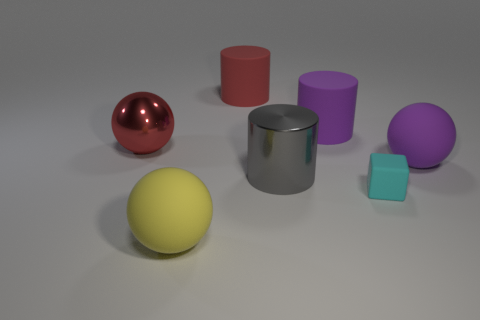There is a large purple object that is in front of the big purple cylinder; what is it made of?
Your answer should be compact. Rubber. What size is the cyan rubber block?
Offer a very short reply. Small. Is the material of the object that is left of the large yellow sphere the same as the gray cylinder?
Offer a very short reply. Yes. What number of small blue rubber cylinders are there?
Provide a succinct answer. 0. What number of objects are either tiny yellow rubber things or big gray shiny cylinders?
Offer a terse response. 1. What number of large purple matte balls are behind the rubber ball that is to the right of the matte ball in front of the cube?
Give a very brief answer. 0. Is there any other thing that is the same color as the block?
Provide a succinct answer. No. There is a big rubber cylinder left of the big gray shiny thing; is it the same color as the metallic object that is left of the red cylinder?
Give a very brief answer. Yes. Are there more objects that are right of the small matte block than gray cylinders left of the red rubber object?
Provide a succinct answer. Yes. What is the big gray cylinder made of?
Your answer should be compact. Metal. 